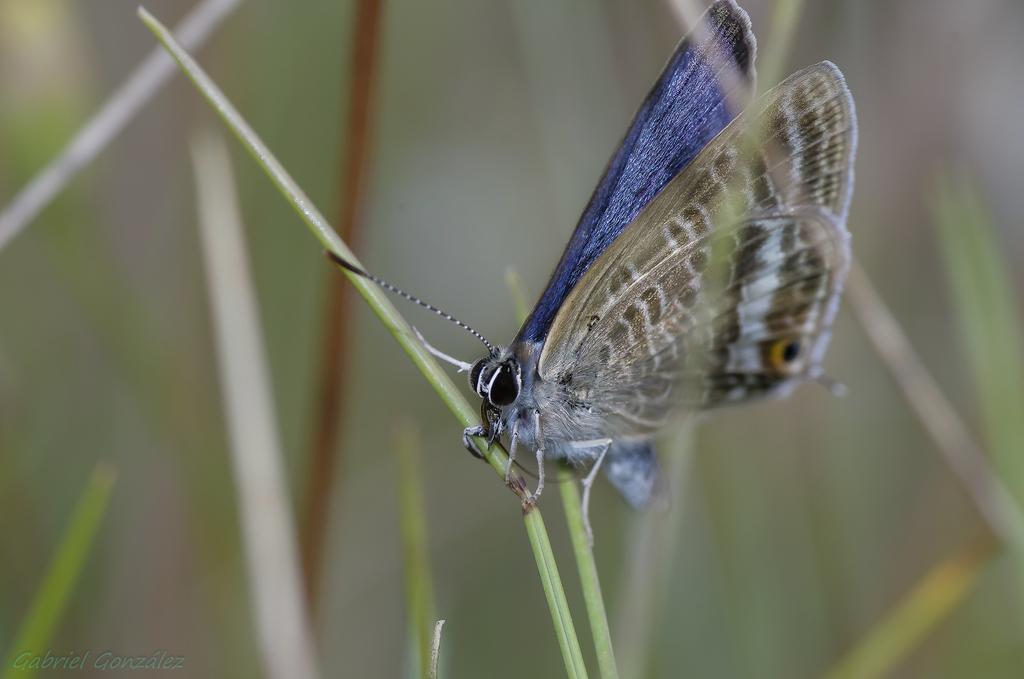Can you describe this image briefly? This picture contains a butterfly, which is in brown and blue color is on the grass. In the background, it is blurred. 